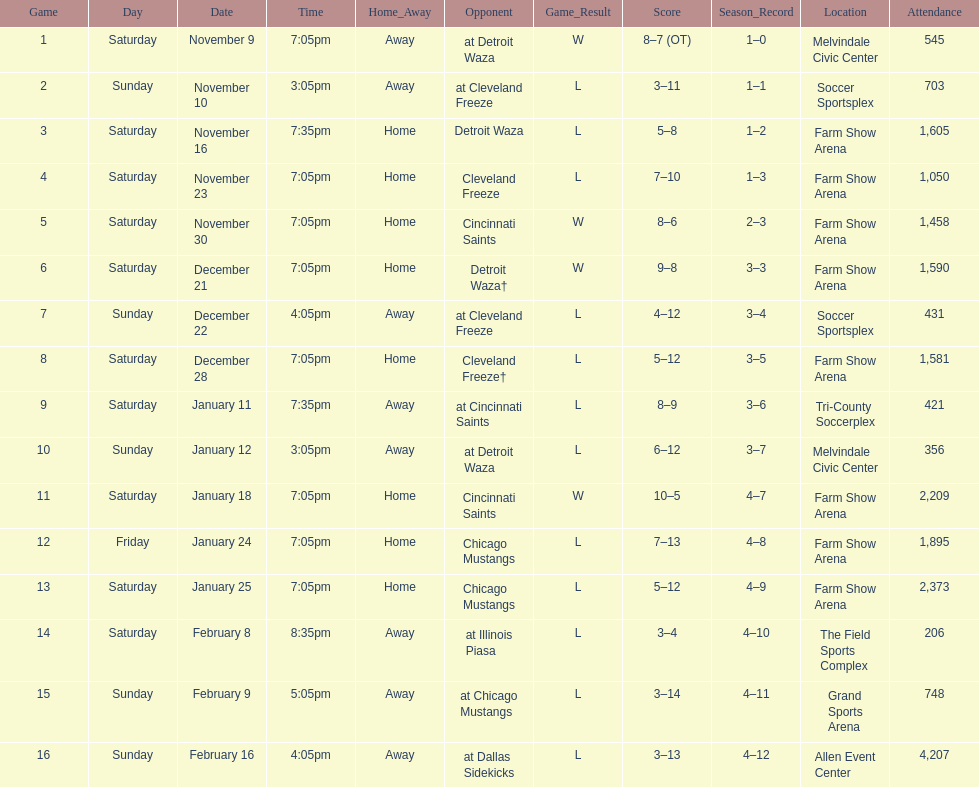What is the date of the game after december 22? December 28. 